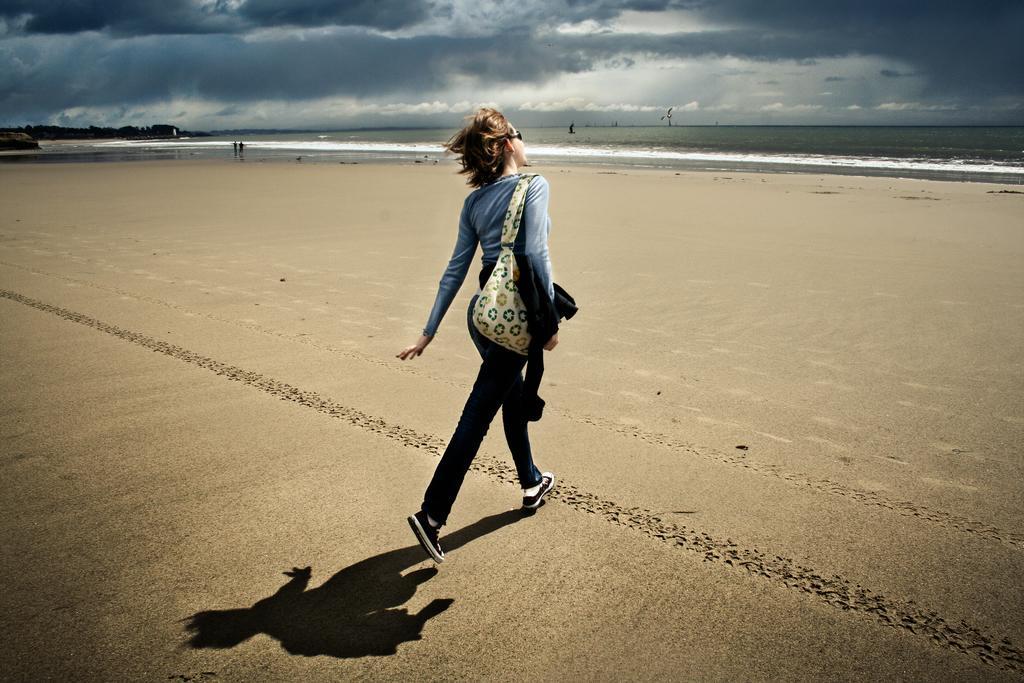In one or two sentences, can you explain what this image depicts? In front of the image there is a person walking on the sand. In the background of the image there are two people standing in the water. There are trees and some other objects. At the top of the image there are clouds in the sky. 